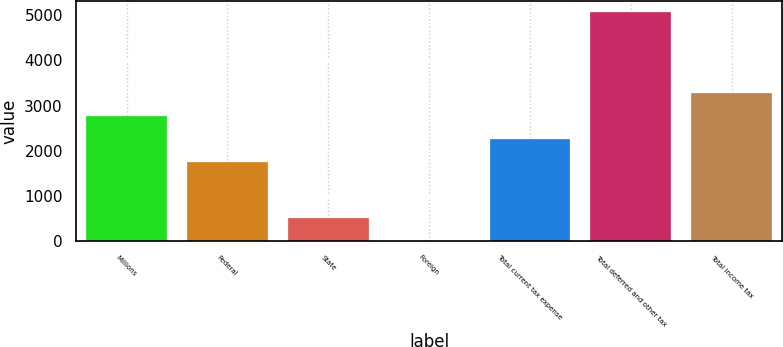<chart> <loc_0><loc_0><loc_500><loc_500><bar_chart><fcel>Millions<fcel>Federal<fcel>State<fcel>Foreign<fcel>Total current tax expense<fcel>Total deferred and other tax<fcel>Total income tax<nl><fcel>2763<fcel>1750<fcel>508.5<fcel>2<fcel>2256.5<fcel>5067<fcel>3269.5<nl></chart> 